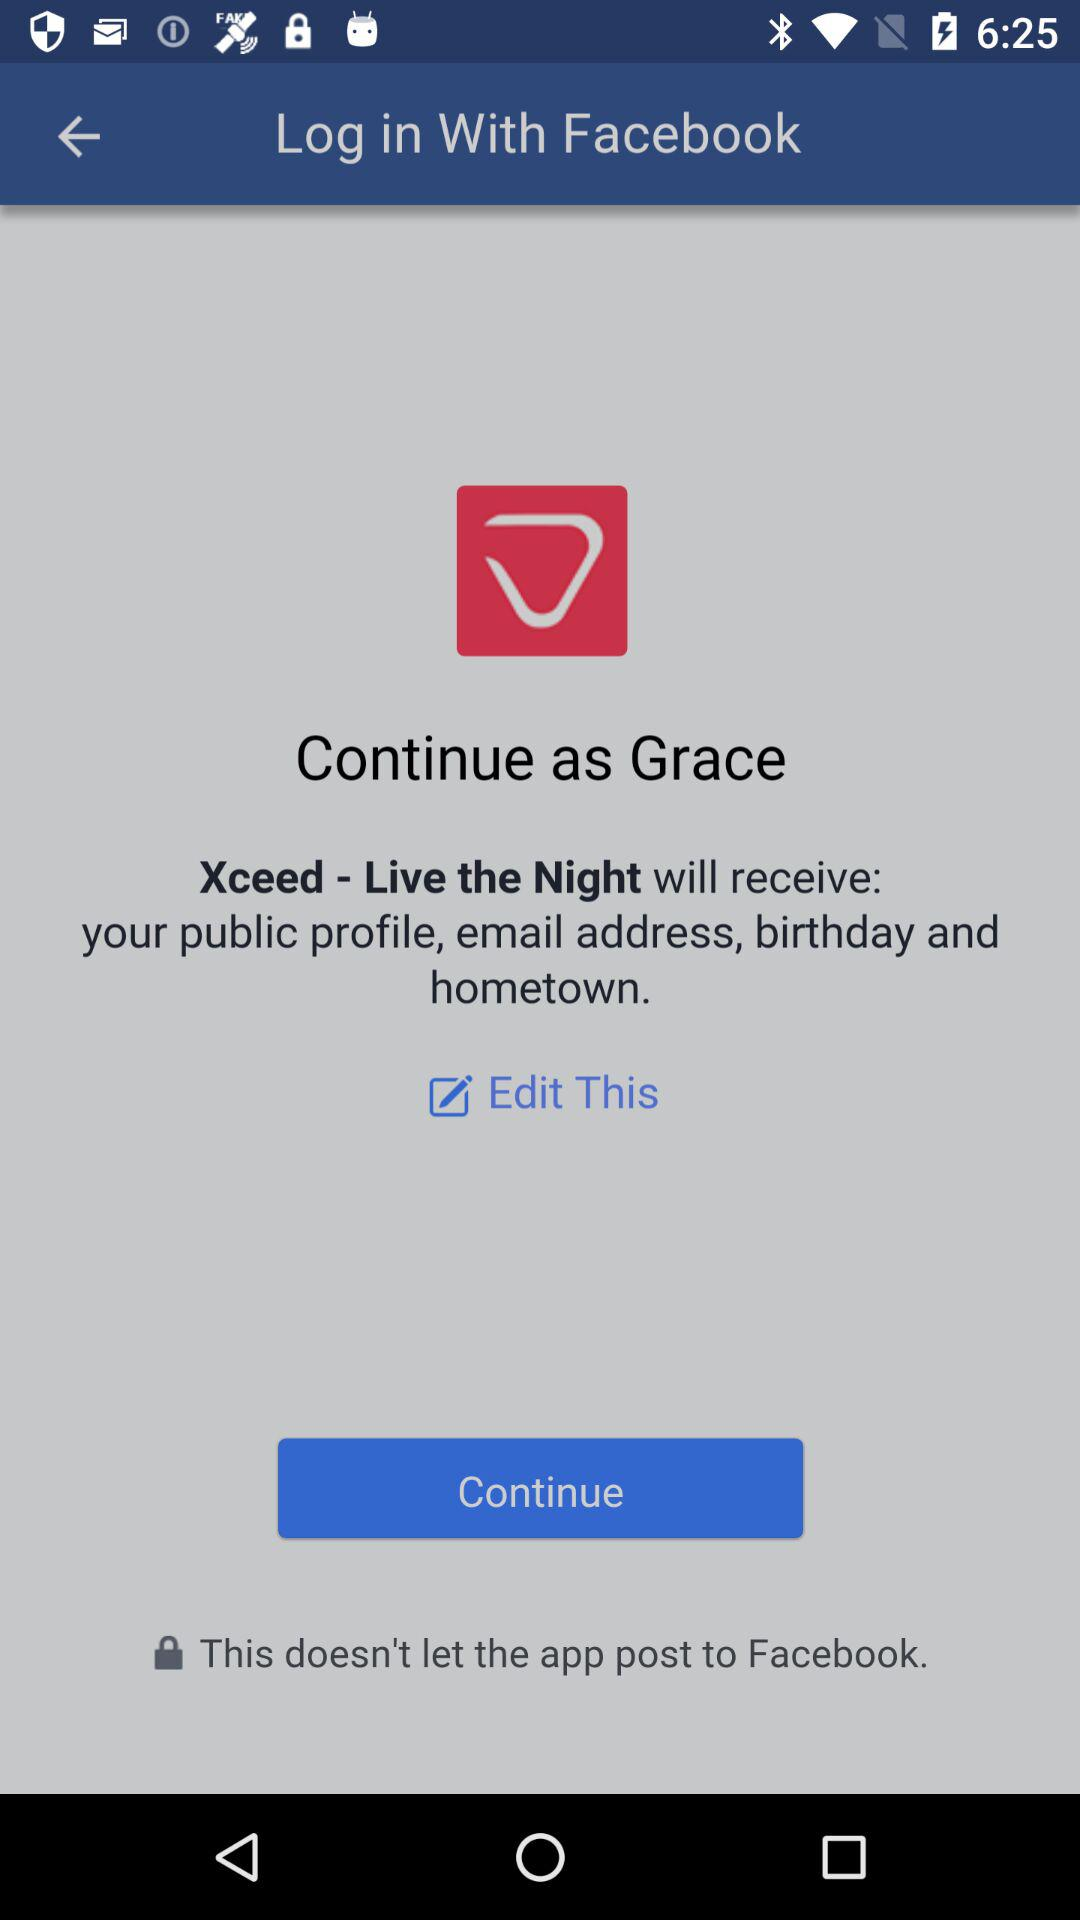Through what application is the person logging in? The person is logging in through "Facebook". 